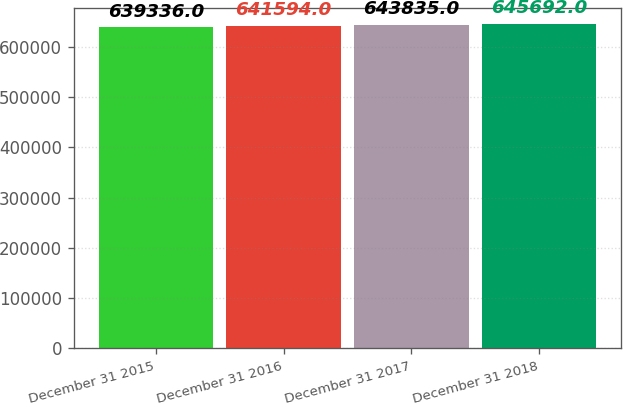Convert chart to OTSL. <chart><loc_0><loc_0><loc_500><loc_500><bar_chart><fcel>December 31 2015<fcel>December 31 2016<fcel>December 31 2017<fcel>December 31 2018<nl><fcel>639336<fcel>641594<fcel>643835<fcel>645692<nl></chart> 